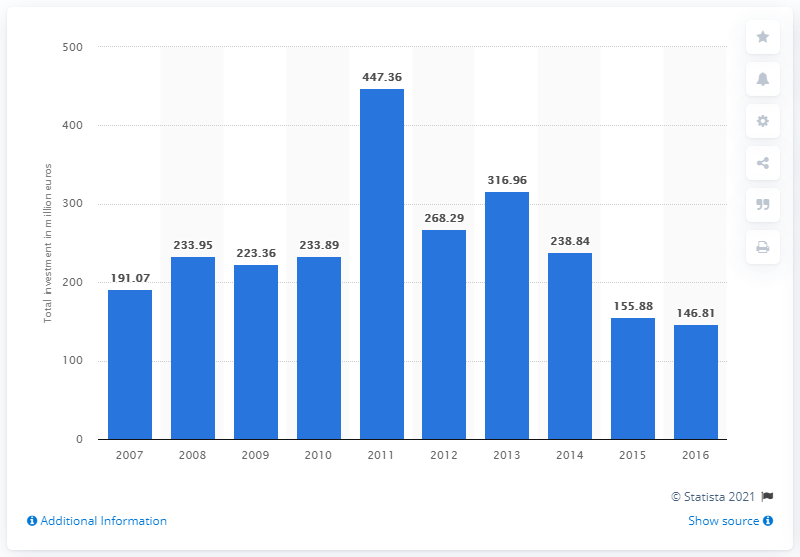Give some essential details in this illustration. In 2016, the total value of private equity investments in Portugal was 146.81. In 2011, the total value of private equity investments in Portugal was 447.36 million. 